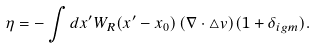Convert formula to latex. <formula><loc_0><loc_0><loc_500><loc_500>\eta = - \int d { x ^ { \prime } } W _ { R } ( { x ^ { \prime } - x } _ { 0 } ) \, ( \nabla \cdot \bigtriangleup { v } ) ( 1 + \delta _ { i g m } ) .</formula> 